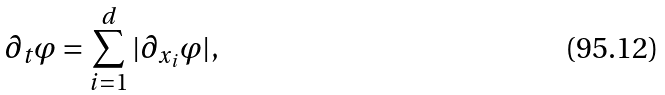<formula> <loc_0><loc_0><loc_500><loc_500>\partial _ { t } \varphi = \sum _ { i = 1 } ^ { d } | \partial _ { x _ { i } } \varphi | ,</formula> 